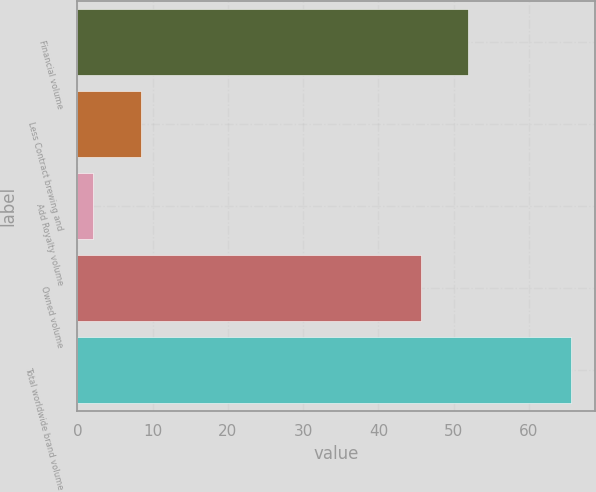<chart> <loc_0><loc_0><loc_500><loc_500><bar_chart><fcel>Financial volume<fcel>Less Contract brewing and<fcel>Add Royalty volume<fcel>Owned volume<fcel>Total worldwide brand volume<nl><fcel>51.94<fcel>8.44<fcel>2.1<fcel>45.6<fcel>65.54<nl></chart> 